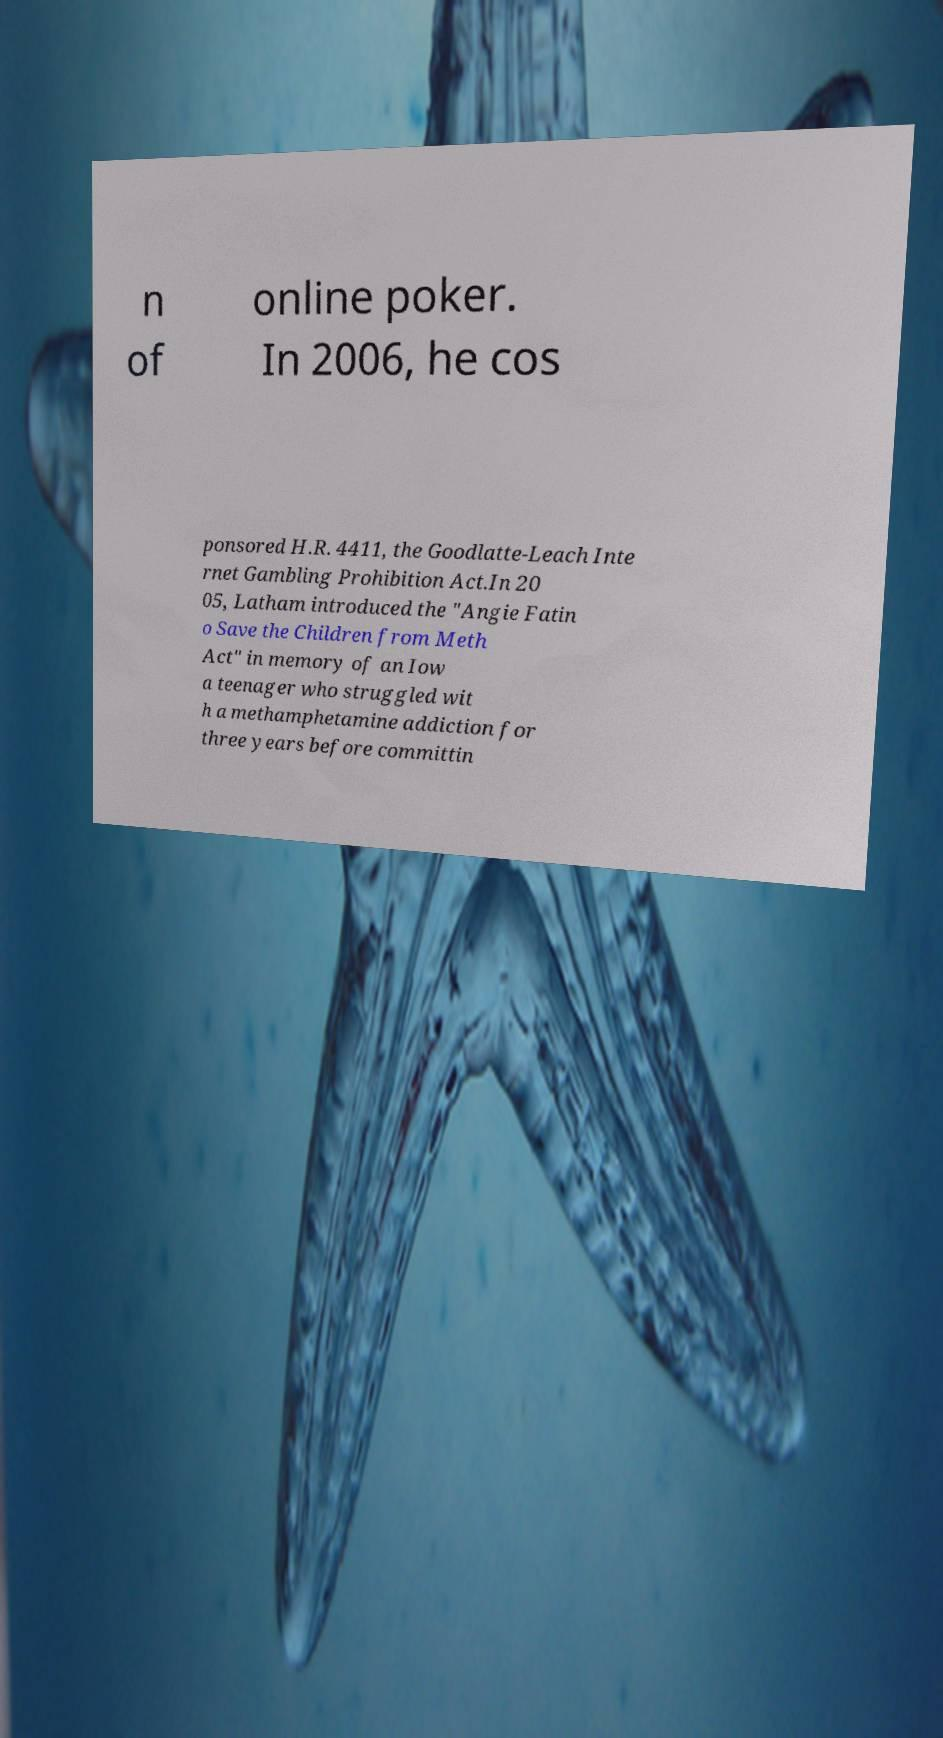There's text embedded in this image that I need extracted. Can you transcribe it verbatim? n of online poker. In 2006, he cos ponsored H.R. 4411, the Goodlatte-Leach Inte rnet Gambling Prohibition Act.In 20 05, Latham introduced the "Angie Fatin o Save the Children from Meth Act" in memory of an Iow a teenager who struggled wit h a methamphetamine addiction for three years before committin 